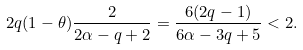<formula> <loc_0><loc_0><loc_500><loc_500>2 q ( 1 - \theta ) \frac { 2 } { 2 \alpha - q + 2 } = \frac { 6 ( 2 q - 1 ) } { 6 \alpha - 3 q + 5 } < 2 .</formula> 